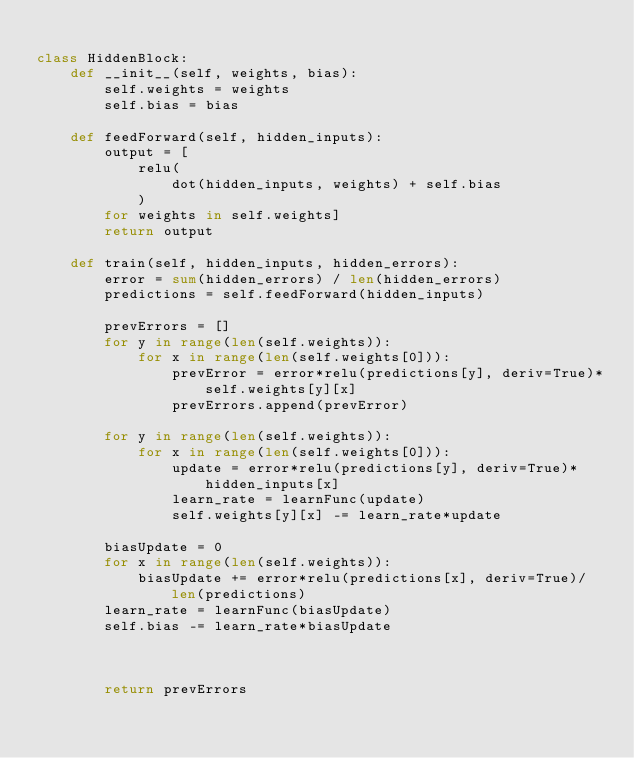Convert code to text. <code><loc_0><loc_0><loc_500><loc_500><_Python_>
class HiddenBlock:
    def __init__(self, weights, bias):
        self.weights = weights
        self.bias = bias

    def feedForward(self, hidden_inputs):
        output = [
            relu(
                dot(hidden_inputs, weights) + self.bias
            ) 
        for weights in self.weights]
        return output

    def train(self, hidden_inputs, hidden_errors):
        error = sum(hidden_errors) / len(hidden_errors)
        predictions = self.feedForward(hidden_inputs)

        prevErrors = []
        for y in range(len(self.weights)):
            for x in range(len(self.weights[0])):
                prevError = error*relu(predictions[y], deriv=True)*self.weights[y][x]
                prevErrors.append(prevError)
                
        for y in range(len(self.weights)):
            for x in range(len(self.weights[0])):
                update = error*relu(predictions[y], deriv=True)*hidden_inputs[x]
                learn_rate = learnFunc(update)
                self.weights[y][x] -= learn_rate*update

        biasUpdate = 0
        for x in range(len(self.weights)):
            biasUpdate += error*relu(predictions[x], deriv=True)/len(predictions)
        learn_rate = learnFunc(biasUpdate)
        self.bias -= learn_rate*biasUpdate

        
        
        return prevErrors</code> 